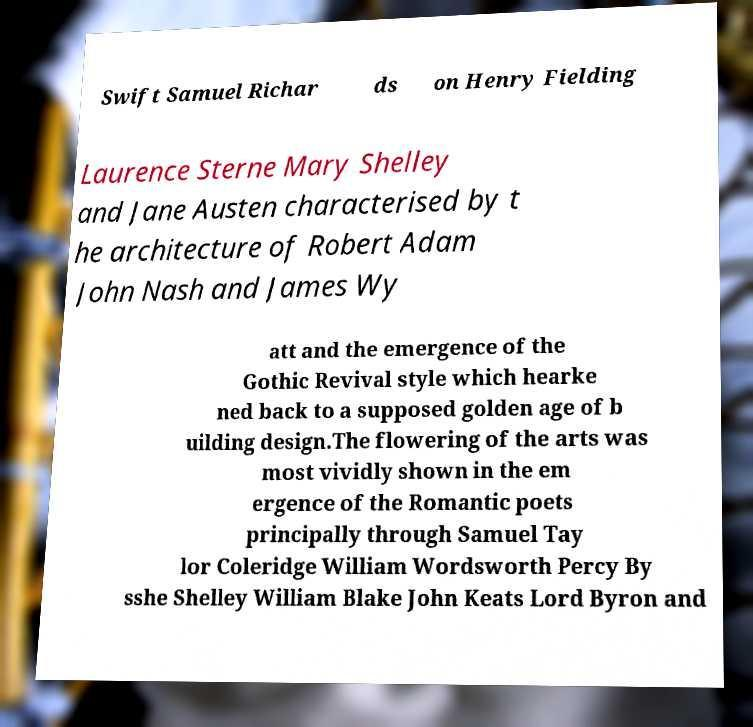Please identify and transcribe the text found in this image. Swift Samuel Richar ds on Henry Fielding Laurence Sterne Mary Shelley and Jane Austen characterised by t he architecture of Robert Adam John Nash and James Wy att and the emergence of the Gothic Revival style which hearke ned back to a supposed golden age of b uilding design.The flowering of the arts was most vividly shown in the em ergence of the Romantic poets principally through Samuel Tay lor Coleridge William Wordsworth Percy By sshe Shelley William Blake John Keats Lord Byron and 